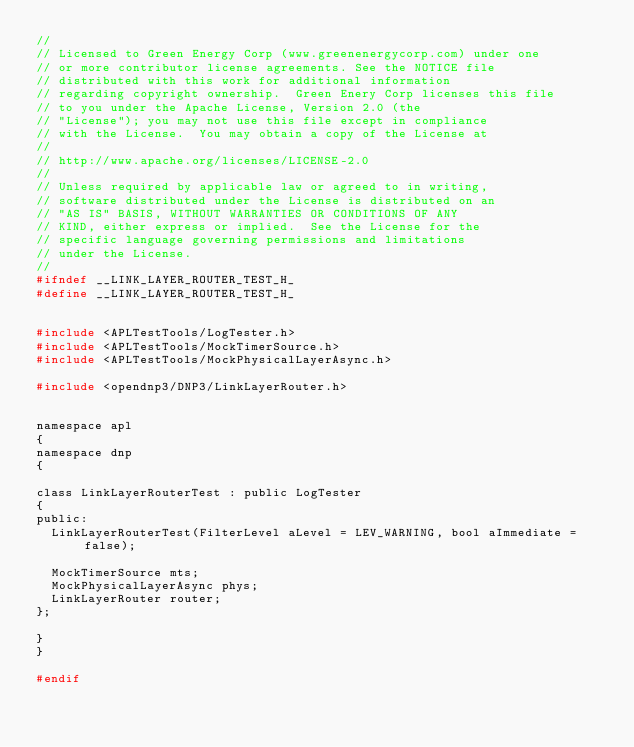<code> <loc_0><loc_0><loc_500><loc_500><_C_>//
// Licensed to Green Energy Corp (www.greenenergycorp.com) under one
// or more contributor license agreements. See the NOTICE file
// distributed with this work for additional information
// regarding copyright ownership.  Green Enery Corp licenses this file
// to you under the Apache License, Version 2.0 (the
// "License"); you may not use this file except in compliance
// with the License.  You may obtain a copy of the License at
//
// http://www.apache.org/licenses/LICENSE-2.0
//
// Unless required by applicable law or agreed to in writing,
// software distributed under the License is distributed on an
// "AS IS" BASIS, WITHOUT WARRANTIES OR CONDITIONS OF ANY
// KIND, either express or implied.  See the License for the
// specific language governing permissions and limitations
// under the License.
//
#ifndef __LINK_LAYER_ROUTER_TEST_H_
#define __LINK_LAYER_ROUTER_TEST_H_


#include <APLTestTools/LogTester.h>
#include <APLTestTools/MockTimerSource.h>
#include <APLTestTools/MockPhysicalLayerAsync.h>

#include <opendnp3/DNP3/LinkLayerRouter.h>


namespace apl
{
namespace dnp
{

class LinkLayerRouterTest : public LogTester
{
public:
	LinkLayerRouterTest(FilterLevel aLevel = LEV_WARNING, bool aImmediate = false);

	MockTimerSource mts;
	MockPhysicalLayerAsync phys;
	LinkLayerRouter router;
};

}
}

#endif
</code> 